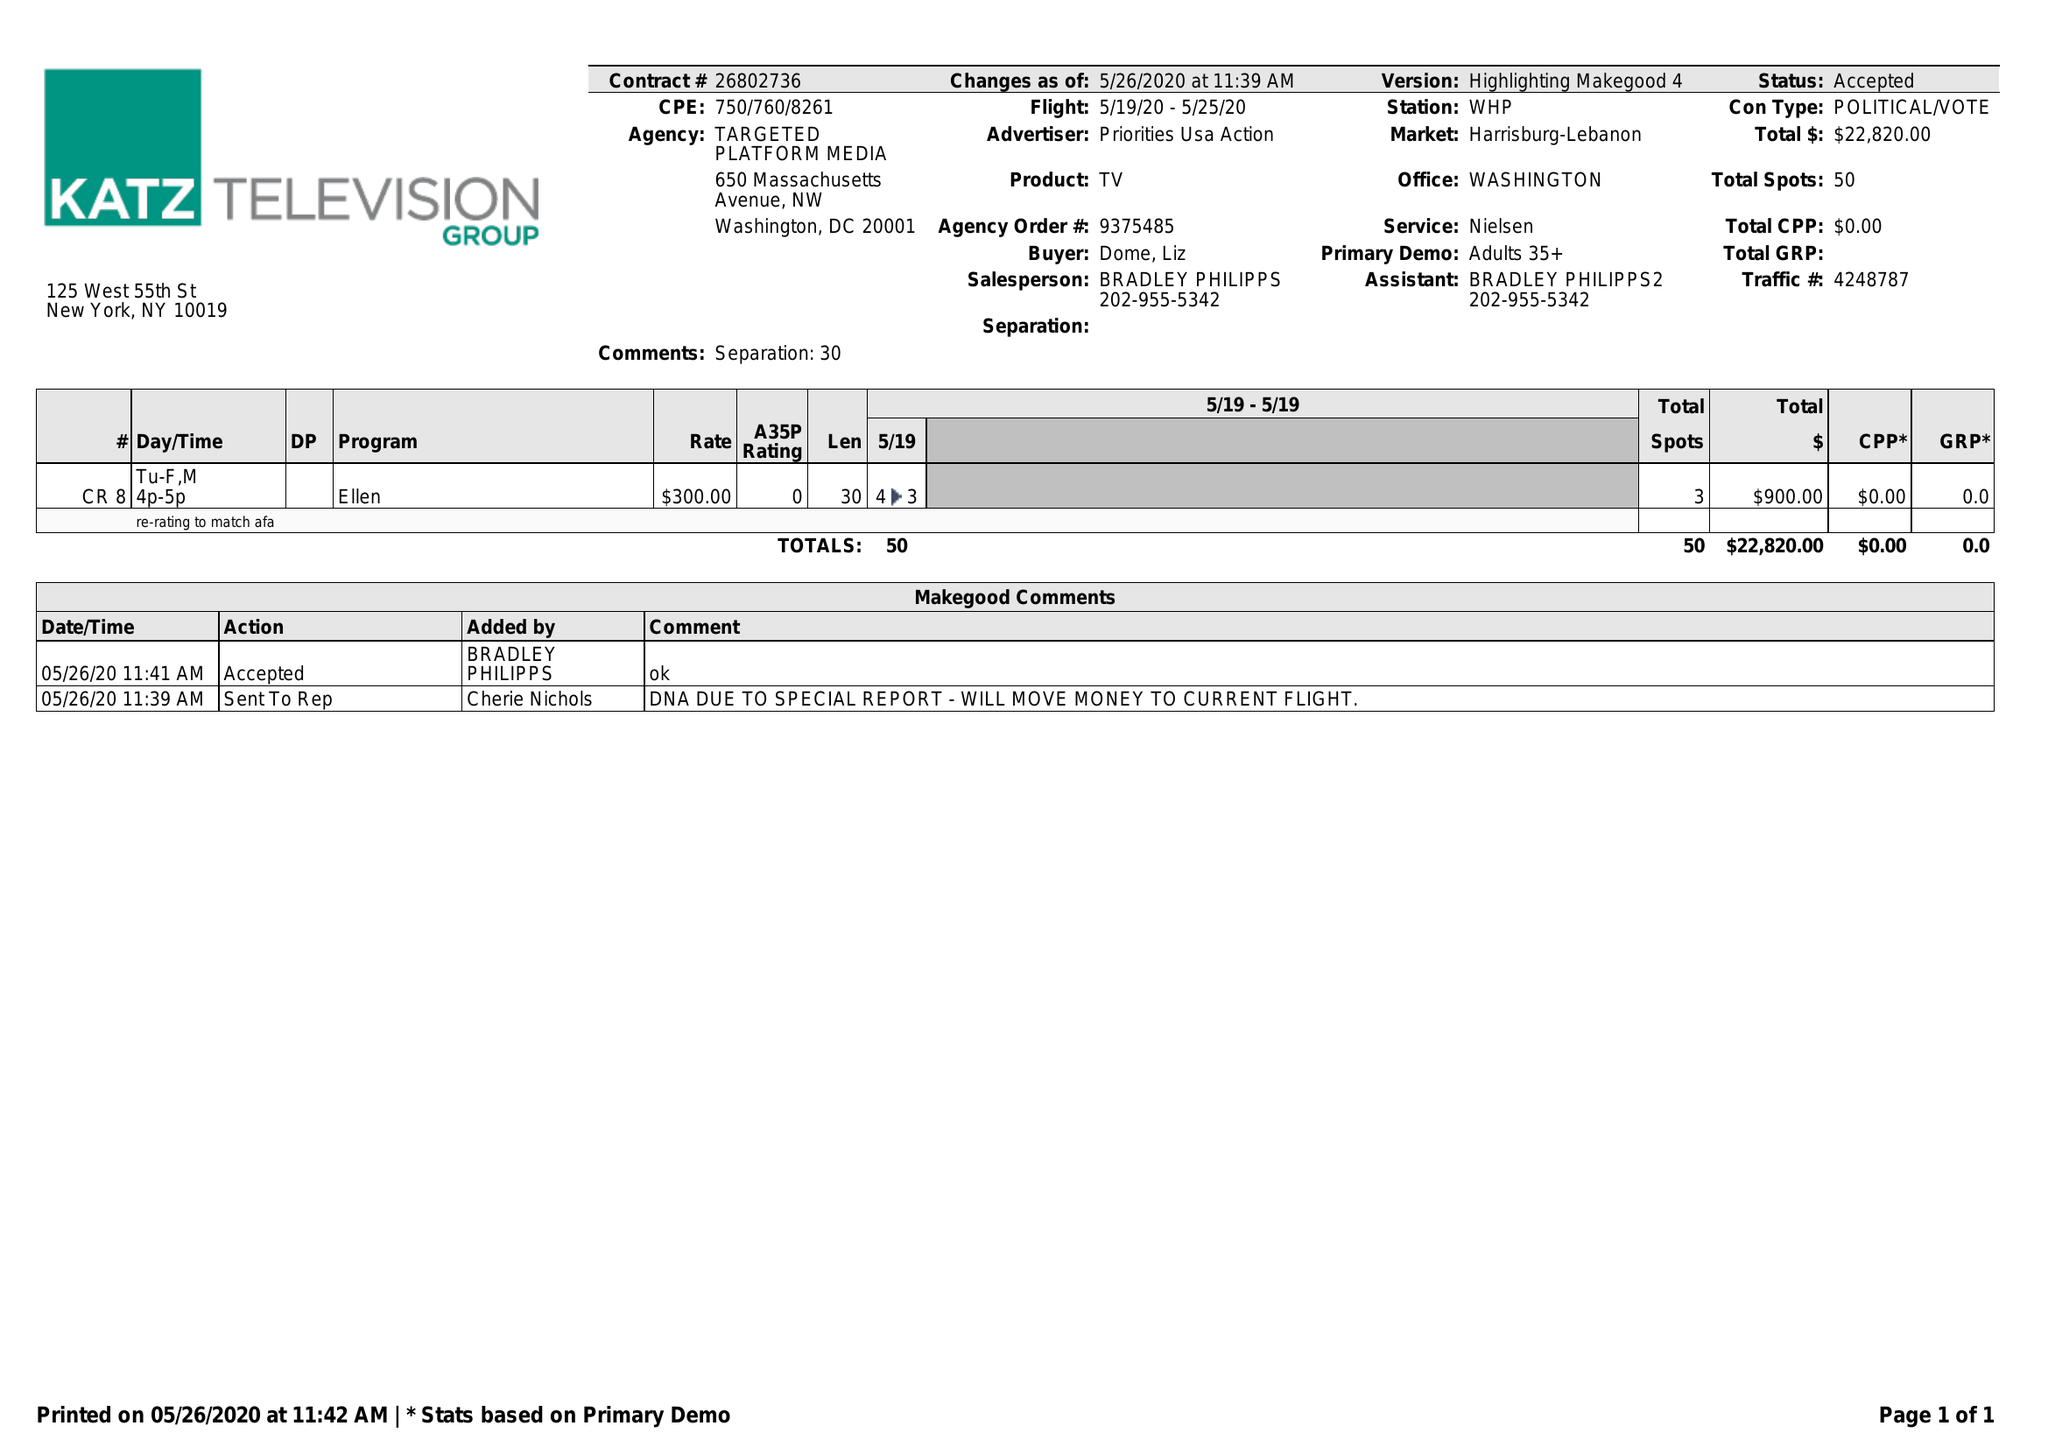What is the value for the advertiser?
Answer the question using a single word or phrase. PRIORITIES USA ACTION 